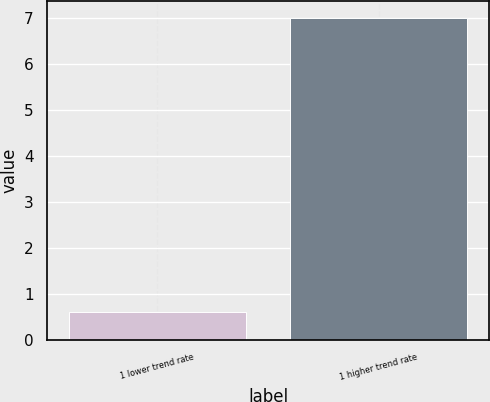<chart> <loc_0><loc_0><loc_500><loc_500><bar_chart><fcel>1 lower trend rate<fcel>1 higher trend rate<nl><fcel>0.6<fcel>7<nl></chart> 